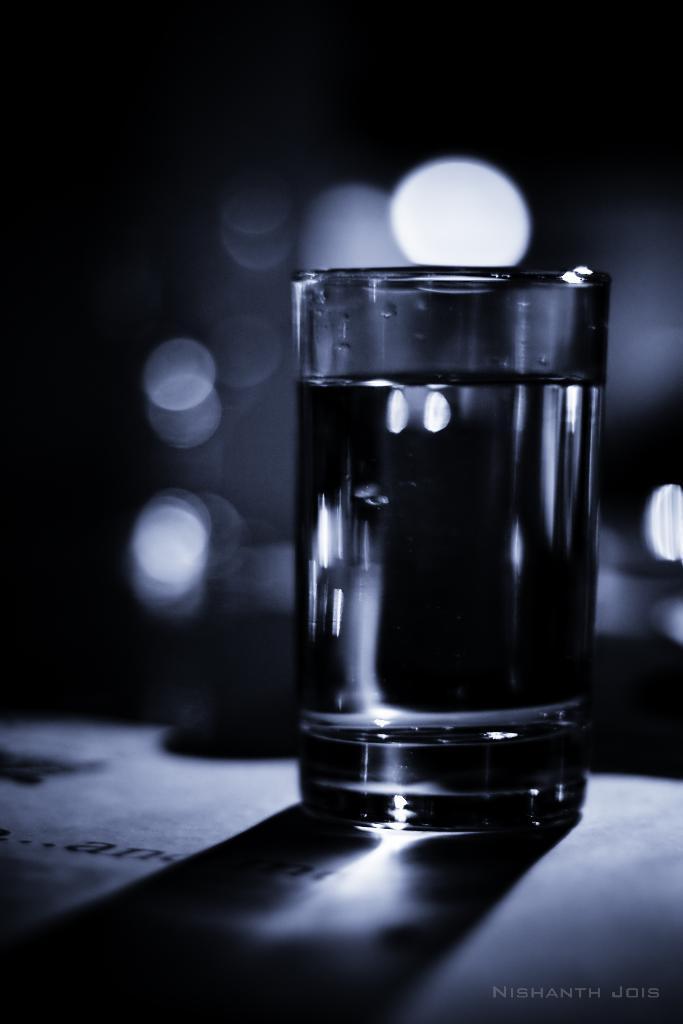How would you summarize this image in a sentence or two? In this picture we can see a glass of drink in the front, there is a blurry background, we can see some text at the right bottom. 